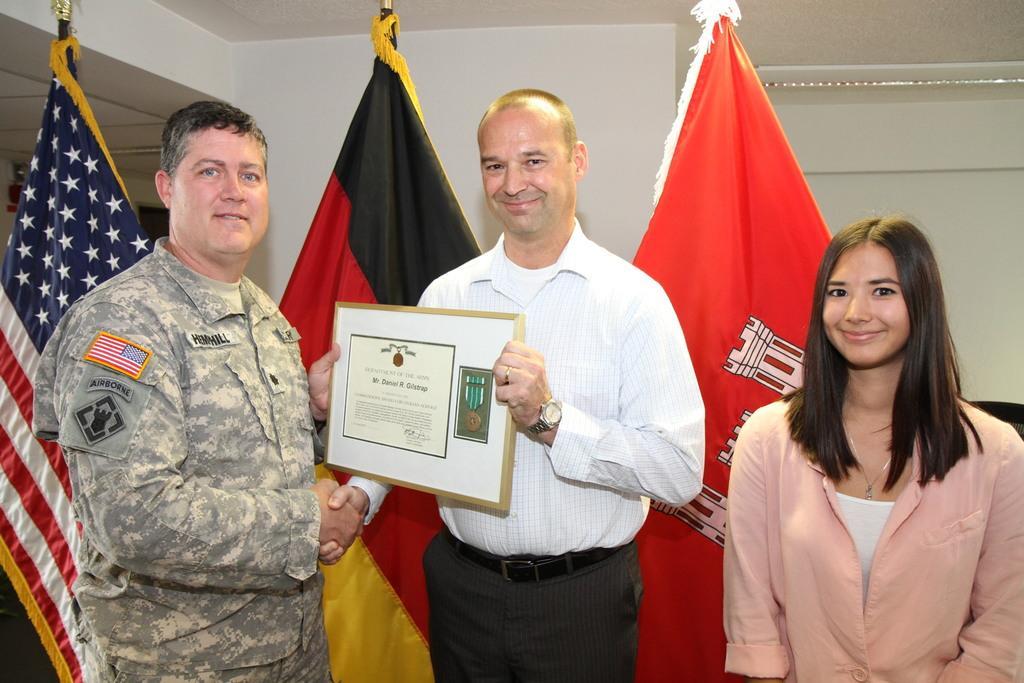Can you describe this image briefly? In this image I can see three people. One is woman, she is standing on the right side, wearing a shirt, smiling and giving pose for the picture. Two are men, they are shaking hands, holding a frame in hands, smiling and giving pose for the picture. The man who is standing on the left side is wearing uniform and another man who is in the middle is wearing a white color shirt. At the back of these people I can see three flags. In the background there is a wall. 